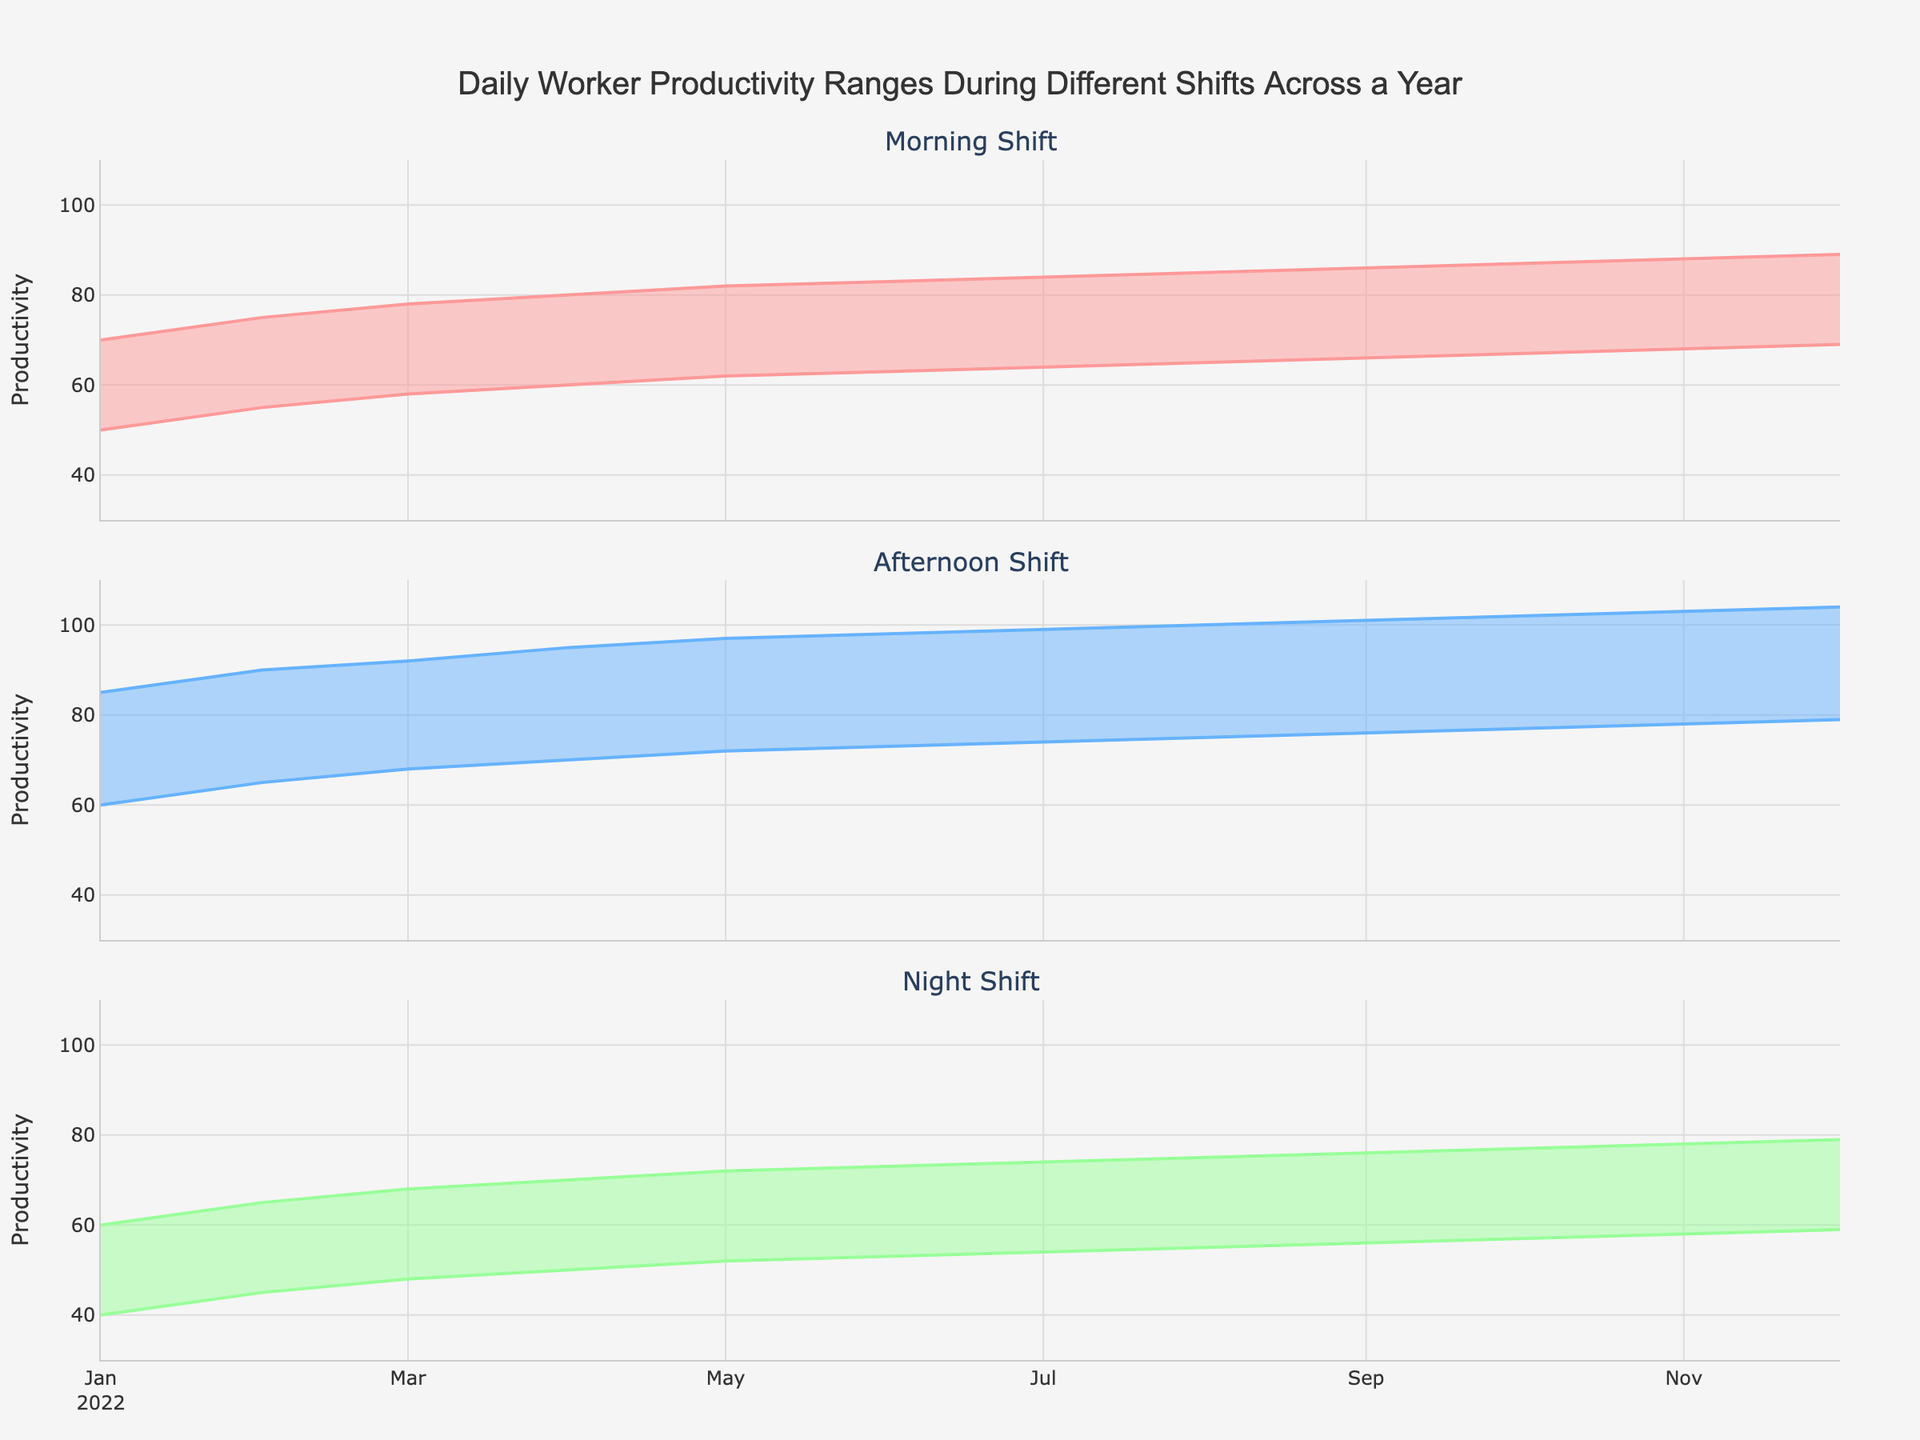What's the title of the chart? The title is located at the top center of the chart and reads "Daily Worker Productivity Ranges During Different Shifts Across a Year".
Answer: "Daily Worker Productivity Ranges During Different Shifts Across a Year" During which shift did the morning shift's minimum productivity reach its highest value? We can observe that the morning shift's minimum productivity reaches its peak in December 2022, with a value of 69.
Answer: December 2022 How did the maximum productivity for the Afternoon shift change from January to December 2022? By looking at the Afternoon shift plots, the maximum productivity starts at 85 in January, gradually increasing month by month, and reaches 104 in December 2022.
Answer: It increased from 85 to 104 What is the range of productivity values for the Night shift in March 2022? In March, the Night shift's productivity range is shown by the area between the two lines indicating minimum and maximum values which are 48 and 68, respectively. The range is calculated as 68 - 48 = 20.
Answer: 20 Which month saw the smallest range of productivity for the Night shift and what was the value? By comparing the filled areas for the Night shifts across all months, April shows the smallest range, which is from 50 to 70. The range is 70 - 50 = 20.
Answer: April with a range of 20 In which month did all shifts see an increase in their maximum productivity compared to the previous month? By inspecting the maximum productivity values for all shifts month by month, May 2022 shows an increase in all shifts compared to April 2022 (Morning: 82 vs 80, Afternoon: 97 vs 95, Night: 72 vs 70).
Answer: May 2022 Which shift had the highest minimum productivity in December 2022? By examining the minimum values for December for all shifts, Afternoon shift shows the highest minimum productivity with a value of 79.
Answer: Afternoon What is the average minimum productivity for the Morning shift over the year? Adding up all the minimum values for the Morning shift (50, 55, 58, 60, 62, 63, 64, 65, 66, 67, 68, 69) and dividing by 12 gives us (50 + 55 + 58 + 60 + 62 + 63 + 64 + 65 + 66 + 67 + 68 + 69) / 12 = 1000 / 12 ≈ 65.83.
Answer: ≈ 65.83 In which month do all shifts have their minimum productivity greater than 50? By checking the plots, from July to December, all shifts have minimum productivity greater than 50.
Answer: July to December 